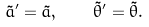<formula> <loc_0><loc_0><loc_500><loc_500>\tilde { a } ^ { \prime } = \tilde { a } , \quad \tilde { \theta } ^ { \prime } = \tilde { \theta } .</formula> 